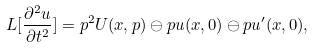Convert formula to latex. <formula><loc_0><loc_0><loc_500><loc_500>L [ \frac { \partial ^ { 2 } u } { \partial t ^ { 2 } } ] = p ^ { 2 } U ( x , p ) \ominus p u ( x , 0 ) \ominus p u ^ { \prime } ( x , 0 ) ,</formula> 